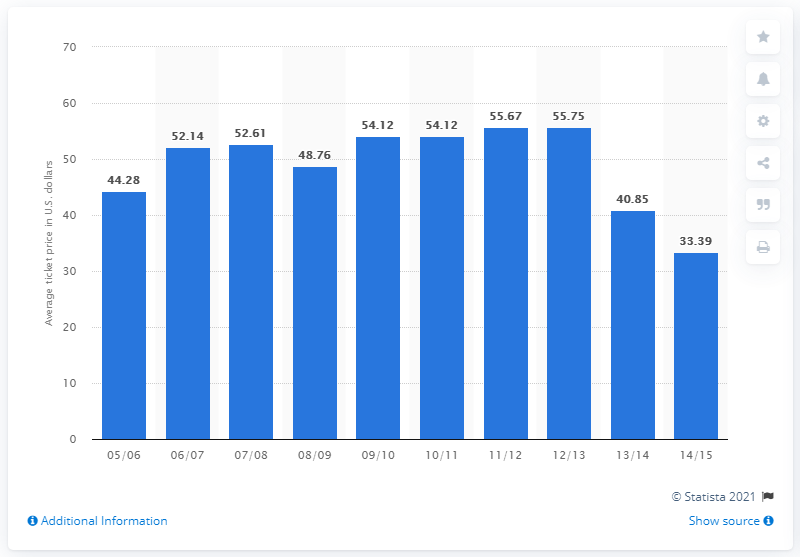Mention a couple of crucial points in this snapshot. The average ticket price for Panthers games in the 2005/2006 season was $44.28. 